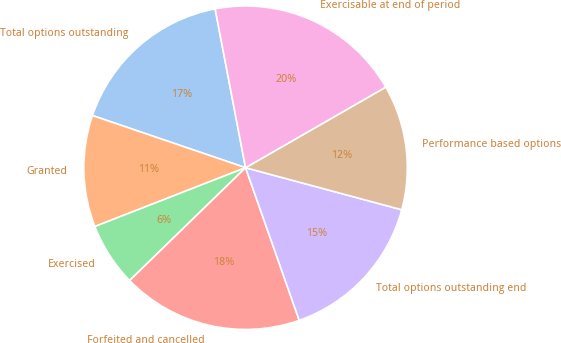Convert chart to OTSL. <chart><loc_0><loc_0><loc_500><loc_500><pie_chart><fcel>Total options outstanding<fcel>Granted<fcel>Exercised<fcel>Forfeited and cancelled<fcel>Total options outstanding end<fcel>Performance based options<fcel>Exercisable at end of period<nl><fcel>16.76%<fcel>11.15%<fcel>6.36%<fcel>18.1%<fcel>15.43%<fcel>12.49%<fcel>19.71%<nl></chart> 